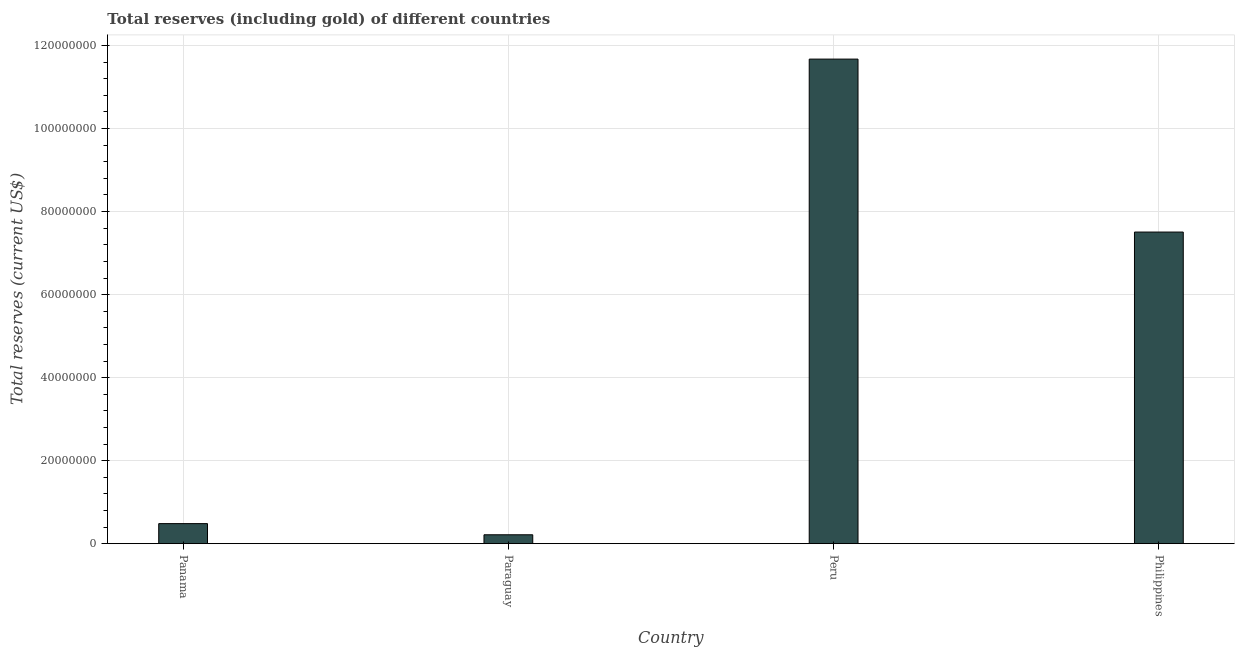Does the graph contain any zero values?
Make the answer very short. No. What is the title of the graph?
Your answer should be compact. Total reserves (including gold) of different countries. What is the label or title of the Y-axis?
Give a very brief answer. Total reserves (current US$). What is the total reserves (including gold) in Peru?
Offer a terse response. 1.17e+08. Across all countries, what is the maximum total reserves (including gold)?
Provide a short and direct response. 1.17e+08. Across all countries, what is the minimum total reserves (including gold)?
Offer a very short reply. 2.14e+06. In which country was the total reserves (including gold) maximum?
Give a very brief answer. Peru. In which country was the total reserves (including gold) minimum?
Give a very brief answer. Paraguay. What is the sum of the total reserves (including gold)?
Provide a succinct answer. 1.99e+08. What is the difference between the total reserves (including gold) in Peru and Philippines?
Provide a short and direct response. 4.17e+07. What is the average total reserves (including gold) per country?
Your answer should be very brief. 4.97e+07. What is the median total reserves (including gold)?
Your answer should be very brief. 3.99e+07. What is the ratio of the total reserves (including gold) in Panama to that in Paraguay?
Your answer should be very brief. 2.26. Is the difference between the total reserves (including gold) in Panama and Philippines greater than the difference between any two countries?
Your answer should be very brief. No. What is the difference between the highest and the second highest total reserves (including gold)?
Provide a short and direct response. 4.17e+07. Is the sum of the total reserves (including gold) in Peru and Philippines greater than the maximum total reserves (including gold) across all countries?
Give a very brief answer. Yes. What is the difference between the highest and the lowest total reserves (including gold)?
Keep it short and to the point. 1.15e+08. In how many countries, is the total reserves (including gold) greater than the average total reserves (including gold) taken over all countries?
Offer a very short reply. 2. How many countries are there in the graph?
Offer a terse response. 4. What is the Total reserves (current US$) in Panama?
Your response must be concise. 4.83e+06. What is the Total reserves (current US$) in Paraguay?
Your answer should be compact. 2.14e+06. What is the Total reserves (current US$) in Peru?
Keep it short and to the point. 1.17e+08. What is the Total reserves (current US$) in Philippines?
Provide a succinct answer. 7.51e+07. What is the difference between the Total reserves (current US$) in Panama and Paraguay?
Keep it short and to the point. 2.69e+06. What is the difference between the Total reserves (current US$) in Panama and Peru?
Give a very brief answer. -1.12e+08. What is the difference between the Total reserves (current US$) in Panama and Philippines?
Ensure brevity in your answer.  -7.02e+07. What is the difference between the Total reserves (current US$) in Paraguay and Peru?
Your response must be concise. -1.15e+08. What is the difference between the Total reserves (current US$) in Paraguay and Philippines?
Your response must be concise. -7.29e+07. What is the difference between the Total reserves (current US$) in Peru and Philippines?
Give a very brief answer. 4.17e+07. What is the ratio of the Total reserves (current US$) in Panama to that in Paraguay?
Make the answer very short. 2.26. What is the ratio of the Total reserves (current US$) in Panama to that in Peru?
Provide a short and direct response. 0.04. What is the ratio of the Total reserves (current US$) in Panama to that in Philippines?
Your answer should be very brief. 0.06. What is the ratio of the Total reserves (current US$) in Paraguay to that in Peru?
Ensure brevity in your answer.  0.02. What is the ratio of the Total reserves (current US$) in Paraguay to that in Philippines?
Your response must be concise. 0.03. What is the ratio of the Total reserves (current US$) in Peru to that in Philippines?
Make the answer very short. 1.55. 